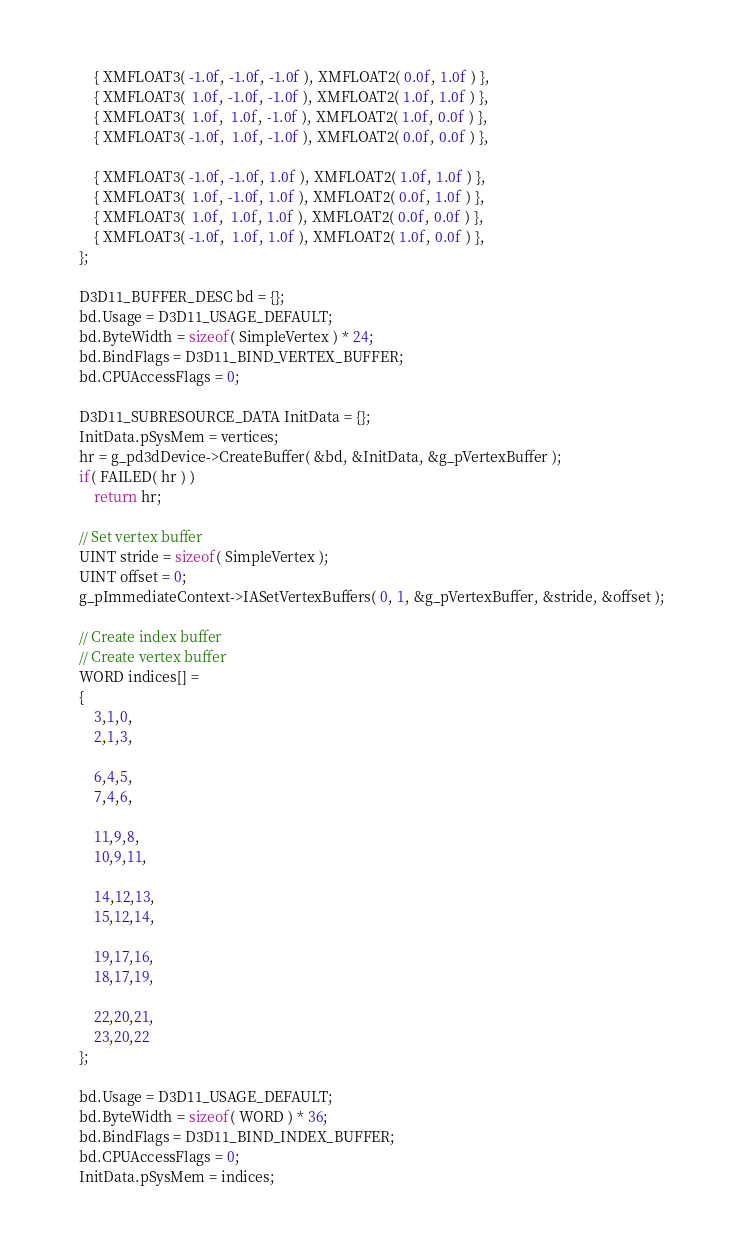<code> <loc_0><loc_0><loc_500><loc_500><_C++_>        { XMFLOAT3( -1.0f, -1.0f, -1.0f ), XMFLOAT2( 0.0f, 1.0f ) },
        { XMFLOAT3(  1.0f, -1.0f, -1.0f ), XMFLOAT2( 1.0f, 1.0f ) },
        { XMFLOAT3(  1.0f,  1.0f, -1.0f ), XMFLOAT2( 1.0f, 0.0f ) },
        { XMFLOAT3( -1.0f,  1.0f, -1.0f ), XMFLOAT2( 0.0f, 0.0f ) },

        { XMFLOAT3( -1.0f, -1.0f, 1.0f ), XMFLOAT2( 1.0f, 1.0f ) },
        { XMFLOAT3(  1.0f, -1.0f, 1.0f ), XMFLOAT2( 0.0f, 1.0f ) },
        { XMFLOAT3(  1.0f,  1.0f, 1.0f ), XMFLOAT2( 0.0f, 0.0f ) },
        { XMFLOAT3( -1.0f,  1.0f, 1.0f ), XMFLOAT2( 1.0f, 0.0f ) },
    };

    D3D11_BUFFER_DESC bd = {};
    bd.Usage = D3D11_USAGE_DEFAULT;
    bd.ByteWidth = sizeof( SimpleVertex ) * 24;
    bd.BindFlags = D3D11_BIND_VERTEX_BUFFER;
    bd.CPUAccessFlags = 0;

    D3D11_SUBRESOURCE_DATA InitData = {};
    InitData.pSysMem = vertices;
    hr = g_pd3dDevice->CreateBuffer( &bd, &InitData, &g_pVertexBuffer );
    if( FAILED( hr ) )
        return hr;

    // Set vertex buffer
    UINT stride = sizeof( SimpleVertex );
    UINT offset = 0;
    g_pImmediateContext->IASetVertexBuffers( 0, 1, &g_pVertexBuffer, &stride, &offset );

    // Create index buffer
    // Create vertex buffer
    WORD indices[] =
    {
        3,1,0,
        2,1,3,

        6,4,5,
        7,4,6,

        11,9,8,
        10,9,11,

        14,12,13,
        15,12,14,

        19,17,16,
        18,17,19,

        22,20,21,
        23,20,22
    };

    bd.Usage = D3D11_USAGE_DEFAULT;
    bd.ByteWidth = sizeof( WORD ) * 36;
    bd.BindFlags = D3D11_BIND_INDEX_BUFFER;
    bd.CPUAccessFlags = 0;
    InitData.pSysMem = indices;</code> 